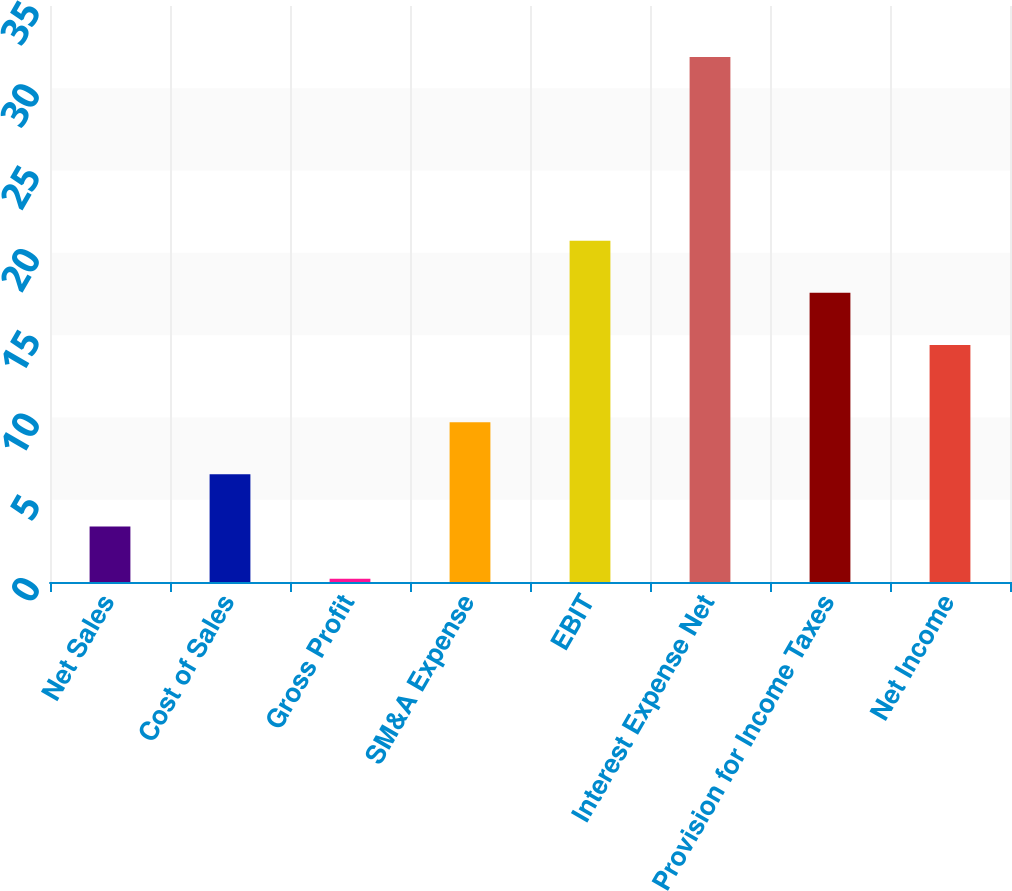Convert chart to OTSL. <chart><loc_0><loc_0><loc_500><loc_500><bar_chart><fcel>Net Sales<fcel>Cost of Sales<fcel>Gross Profit<fcel>SM&A Expense<fcel>EBIT<fcel>Interest Expense Net<fcel>Provision for Income Taxes<fcel>Net Income<nl><fcel>3.37<fcel>6.54<fcel>0.2<fcel>9.71<fcel>20.74<fcel>31.9<fcel>17.57<fcel>14.4<nl></chart> 